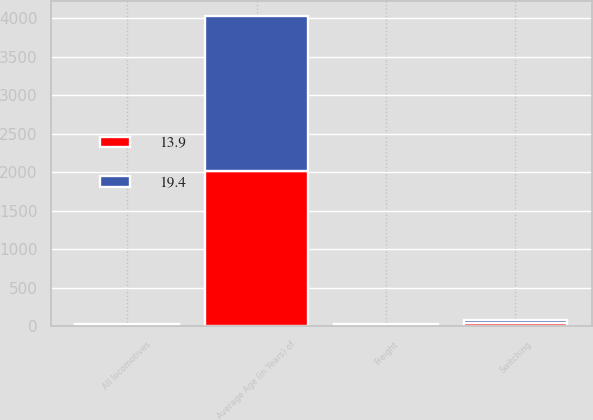<chart> <loc_0><loc_0><loc_500><loc_500><stacked_bar_chart><ecel><fcel>Average Age (in Years) of<fcel>Freight<fcel>Switching<fcel>All locomotives<nl><fcel>13.9<fcel>2014<fcel>18.6<fcel>39<fcel>13.9<nl><fcel>19.4<fcel>2013<fcel>16<fcel>37.2<fcel>19.4<nl></chart> 